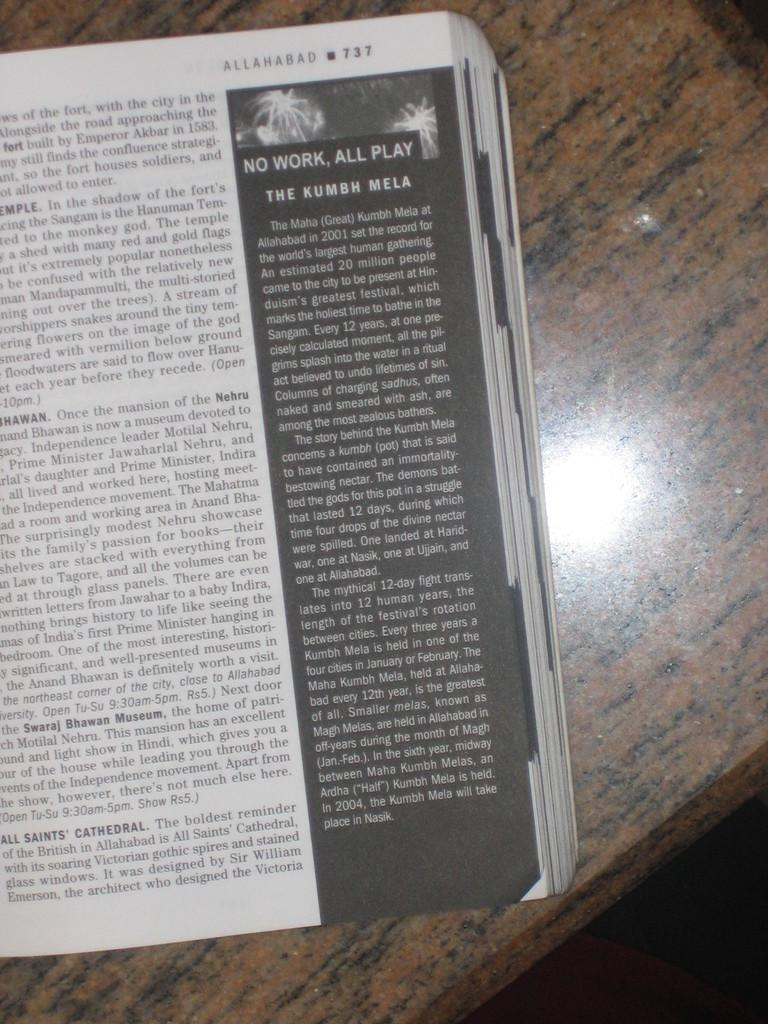<image>
Write a terse but informative summary of the picture. a book open to a page reading "No Work, All Play" 